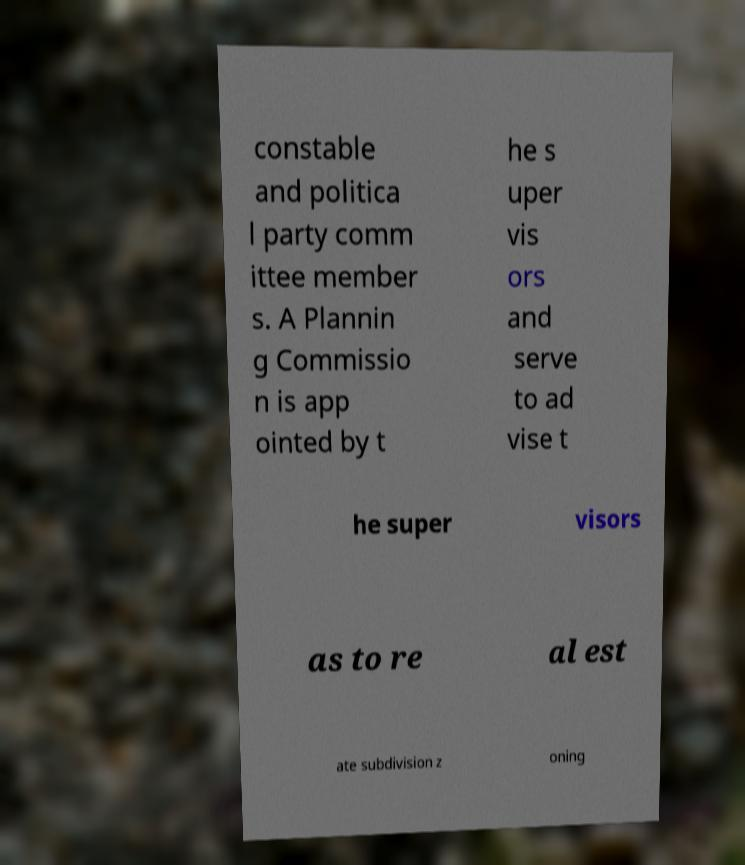Could you assist in decoding the text presented in this image and type it out clearly? constable and politica l party comm ittee member s. A Plannin g Commissio n is app ointed by t he s uper vis ors and serve to ad vise t he super visors as to re al est ate subdivision z oning 